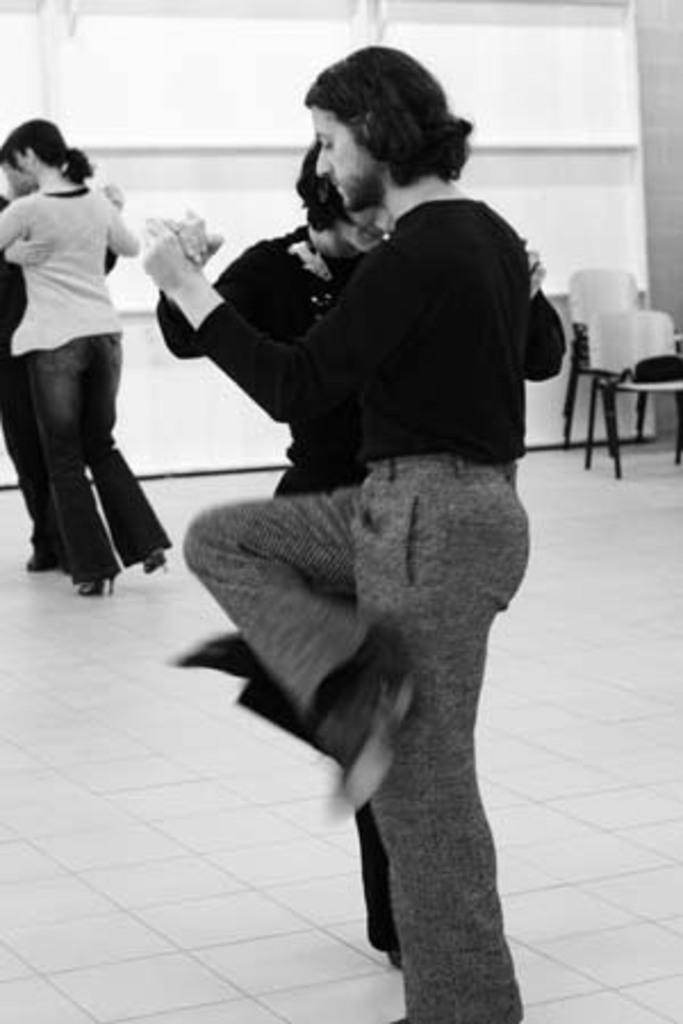Could you give a brief overview of what you see in this image? In this image I can see some people are holding each other and dancing, side I can see some chairs and glass windows to the wall. 